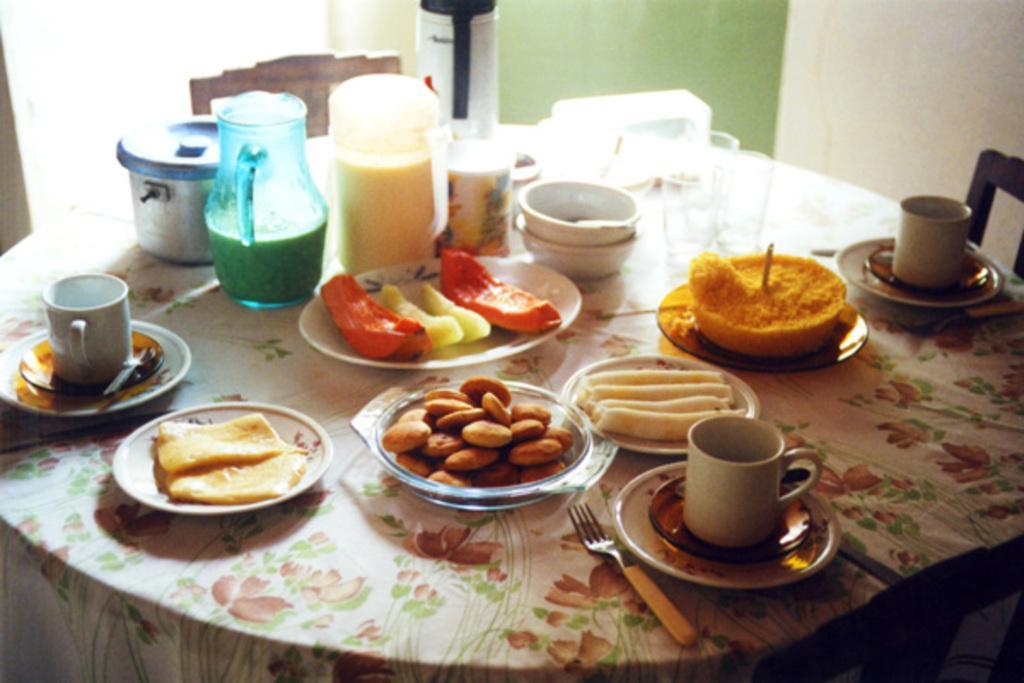Please provide a concise description of this image. In this image, There is a table which is covered by a cloth on that table there are some food items and there are some glasses and there are some plates and there is a jug which is in green and yellow color, In the background there is a chair which is in brown color and there is a wall which is in green color. 